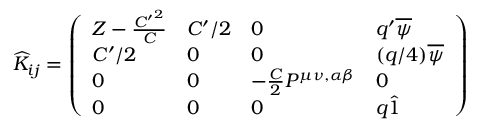Convert formula to latex. <formula><loc_0><loc_0><loc_500><loc_500>\widehat { K } _ { i j } = \left ( \begin{array} { l l l l } { { Z - { \frac { { C ^ { \prime } } ^ { 2 } } { C } } } } & { { C ^ { \prime } / 2 } } & { 0 } & { { q ^ { \prime } \overline { \psi } } } \\ { { C ^ { \prime } / 2 } } & { 0 } & { 0 } & { { ( q / 4 ) \overline { \psi } } } \\ { 0 } & { 0 } & { { - { \frac { C } { 2 } } P ^ { \mu \nu , \alpha \beta } } } & { 0 } \\ { 0 } & { 0 } & { 0 } & { { q \hat { 1 } } } \end{array} \right )</formula> 